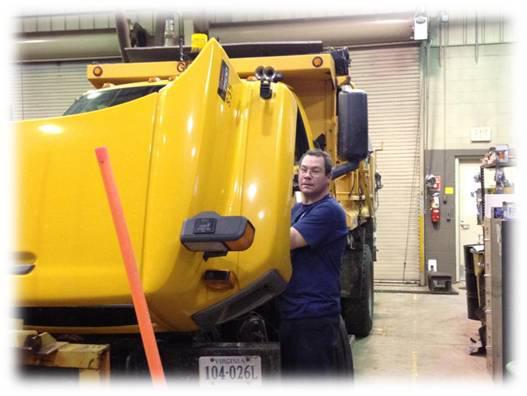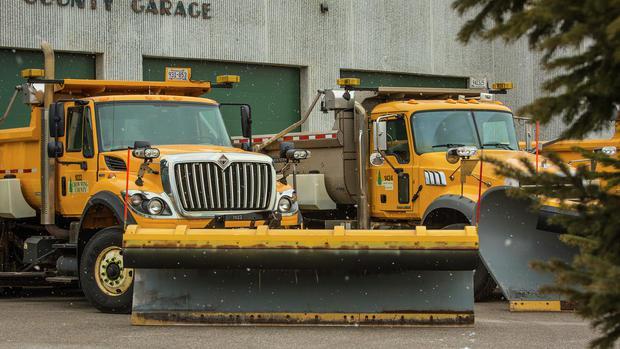The first image is the image on the left, the second image is the image on the right. Analyze the images presented: Is the assertion "A person is standing near a yellow heavy duty truck." valid? Answer yes or no. Yes. The first image is the image on the left, the second image is the image on the right. For the images shown, is this caption "In one image, on a snowy street, a yellow snow blade is attached to a dark truck with extra headlights." true? Answer yes or no. No. 